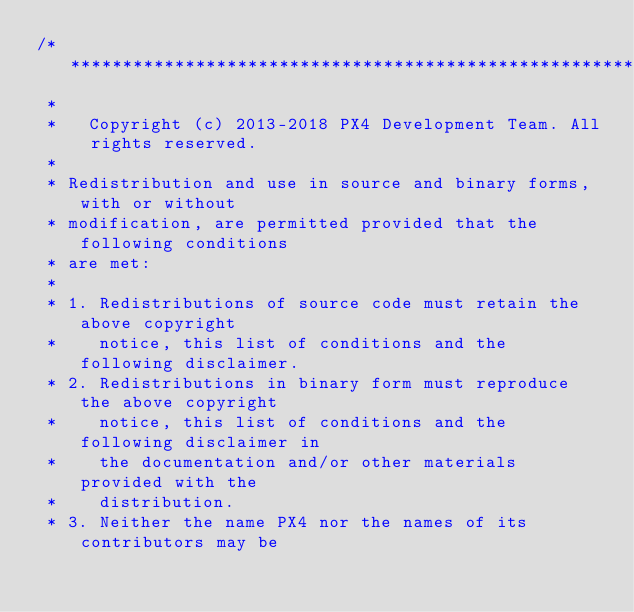Convert code to text. <code><loc_0><loc_0><loc_500><loc_500><_C++_>/****************************************************************************
 *
 *   Copyright (c) 2013-2018 PX4 Development Team. All rights reserved.
 *
 * Redistribution and use in source and binary forms, with or without
 * modification, are permitted provided that the following conditions
 * are met:
 *
 * 1. Redistributions of source code must retain the above copyright
 *    notice, this list of conditions and the following disclaimer.
 * 2. Redistributions in binary form must reproduce the above copyright
 *    notice, this list of conditions and the following disclaimer in
 *    the documentation and/or other materials provided with the
 *    distribution.
 * 3. Neither the name PX4 nor the names of its contributors may be</code> 